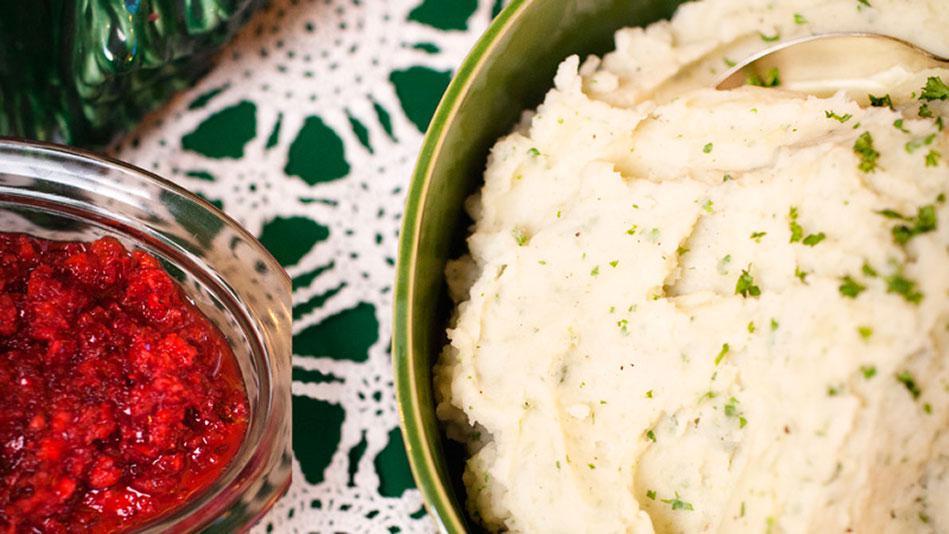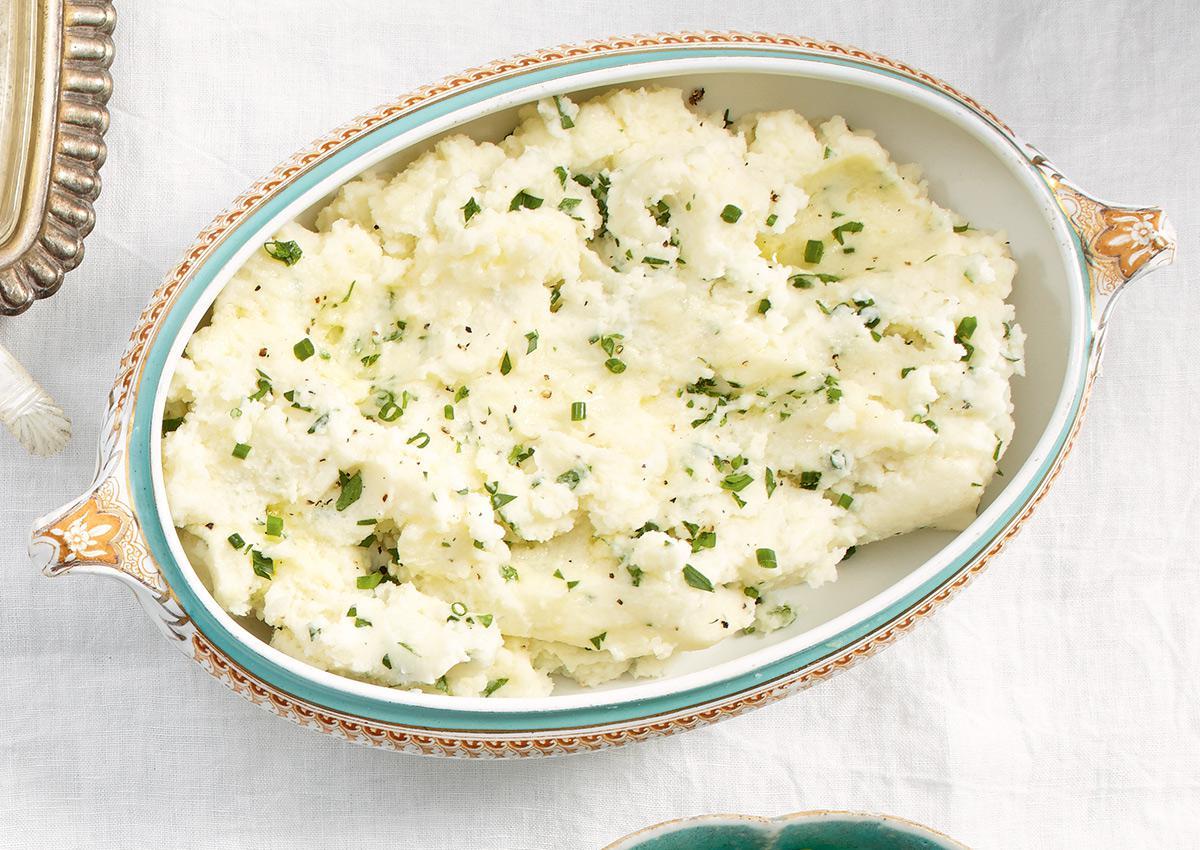The first image is the image on the left, the second image is the image on the right. Examine the images to the left and right. Is the description "One image shows potatoes garnished with green bits and served in a shiny olive green bowl." accurate? Answer yes or no. Yes. The first image is the image on the left, the second image is the image on the right. For the images displayed, is the sentence "In one of the images, the mashed potatoes are in a green bowl." factually correct? Answer yes or no. Yes. 